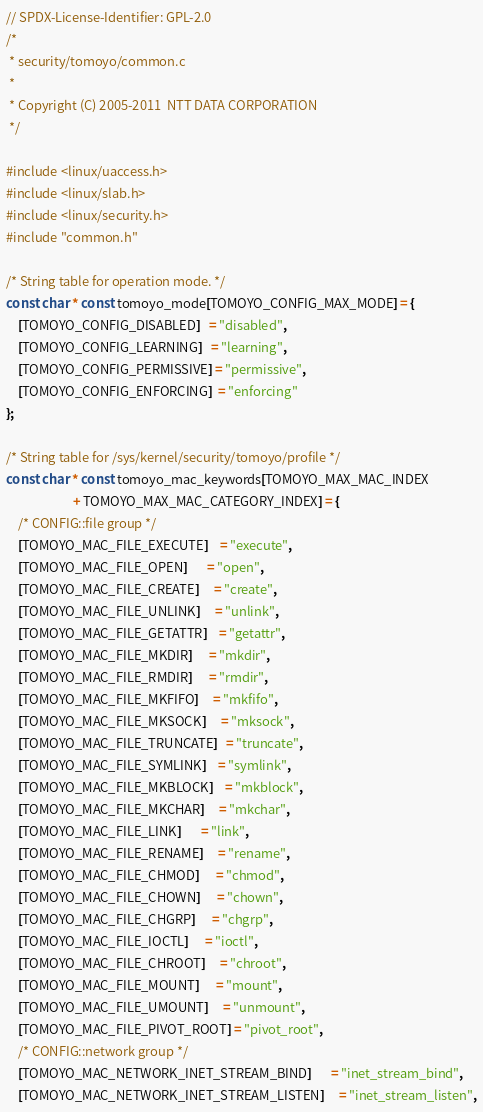Convert code to text. <code><loc_0><loc_0><loc_500><loc_500><_C_>// SPDX-License-Identifier: GPL-2.0
/*
 * security/tomoyo/common.c
 *
 * Copyright (C) 2005-2011  NTT DATA CORPORATION
 */

#include <linux/uaccess.h>
#include <linux/slab.h>
#include <linux/security.h>
#include "common.h"

/* String table for operation mode. */
const char * const tomoyo_mode[TOMOYO_CONFIG_MAX_MODE] = {
	[TOMOYO_CONFIG_DISABLED]   = "disabled",
	[TOMOYO_CONFIG_LEARNING]   = "learning",
	[TOMOYO_CONFIG_PERMISSIVE] = "permissive",
	[TOMOYO_CONFIG_ENFORCING]  = "enforcing"
};

/* String table for /sys/kernel/security/tomoyo/profile */
const char * const tomoyo_mac_keywords[TOMOYO_MAX_MAC_INDEX
				       + TOMOYO_MAX_MAC_CATEGORY_INDEX] = {
	/* CONFIG::file group */
	[TOMOYO_MAC_FILE_EXECUTE]    = "execute",
	[TOMOYO_MAC_FILE_OPEN]       = "open",
	[TOMOYO_MAC_FILE_CREATE]     = "create",
	[TOMOYO_MAC_FILE_UNLINK]     = "unlink",
	[TOMOYO_MAC_FILE_GETATTR]    = "getattr",
	[TOMOYO_MAC_FILE_MKDIR]      = "mkdir",
	[TOMOYO_MAC_FILE_RMDIR]      = "rmdir",
	[TOMOYO_MAC_FILE_MKFIFO]     = "mkfifo",
	[TOMOYO_MAC_FILE_MKSOCK]     = "mksock",
	[TOMOYO_MAC_FILE_TRUNCATE]   = "truncate",
	[TOMOYO_MAC_FILE_SYMLINK]    = "symlink",
	[TOMOYO_MAC_FILE_MKBLOCK]    = "mkblock",
	[TOMOYO_MAC_FILE_MKCHAR]     = "mkchar",
	[TOMOYO_MAC_FILE_LINK]       = "link",
	[TOMOYO_MAC_FILE_RENAME]     = "rename",
	[TOMOYO_MAC_FILE_CHMOD]      = "chmod",
	[TOMOYO_MAC_FILE_CHOWN]      = "chown",
	[TOMOYO_MAC_FILE_CHGRP]      = "chgrp",
	[TOMOYO_MAC_FILE_IOCTL]      = "ioctl",
	[TOMOYO_MAC_FILE_CHROOT]     = "chroot",
	[TOMOYO_MAC_FILE_MOUNT]      = "mount",
	[TOMOYO_MAC_FILE_UMOUNT]     = "unmount",
	[TOMOYO_MAC_FILE_PIVOT_ROOT] = "pivot_root",
	/* CONFIG::network group */
	[TOMOYO_MAC_NETWORK_INET_STREAM_BIND]       = "inet_stream_bind",
	[TOMOYO_MAC_NETWORK_INET_STREAM_LISTEN]     = "inet_stream_listen",</code> 